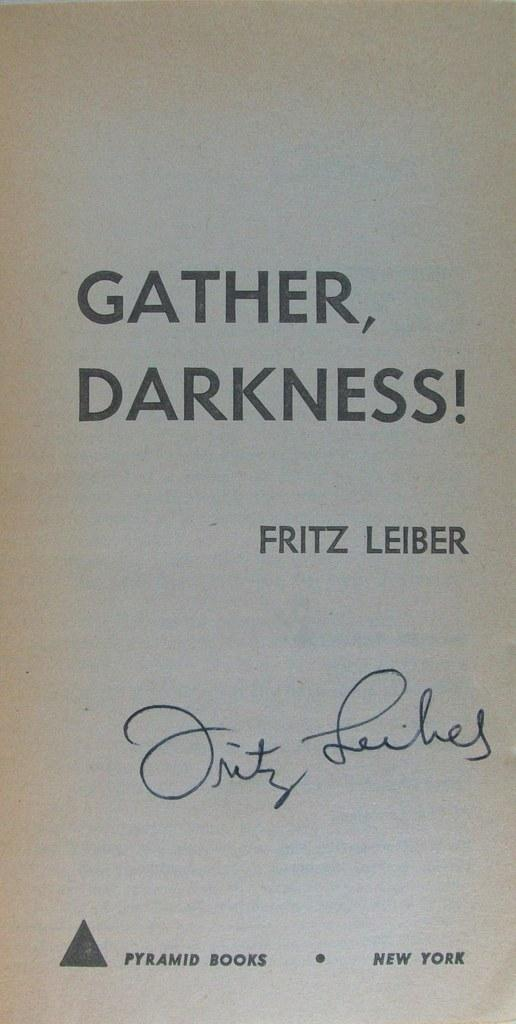<image>
Provide a brief description of the given image. A signed book cover of Gather, Darkness! by Fritz Leiber. 